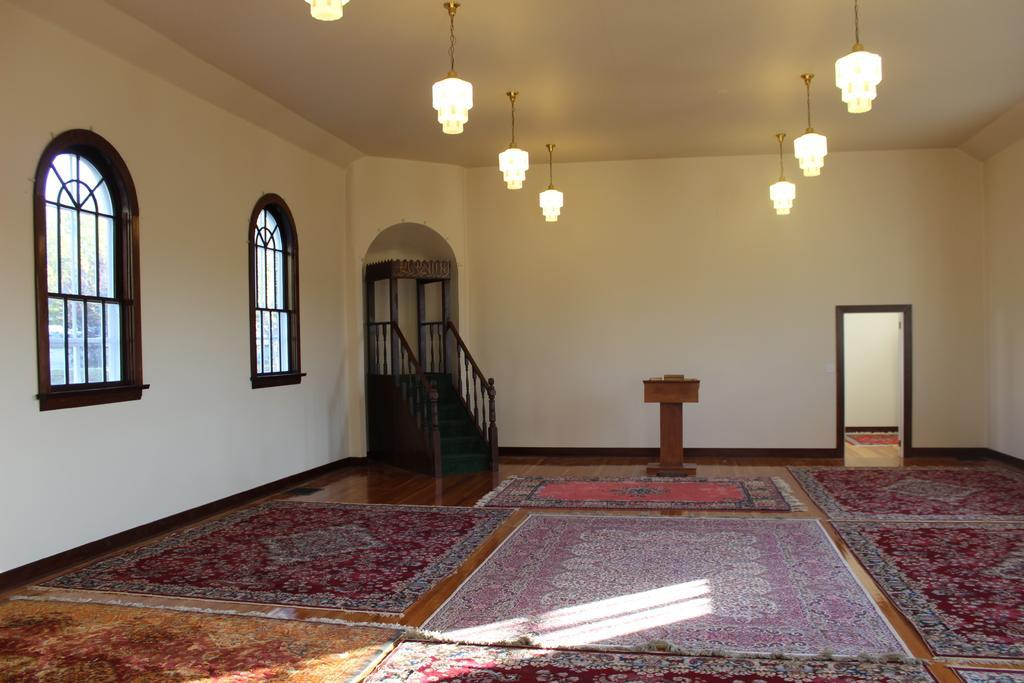How would you summarize this image in a sentence or two? This image might be taken in room. In this image we can see door, stairs, windows, lights, lectern and carpets. 